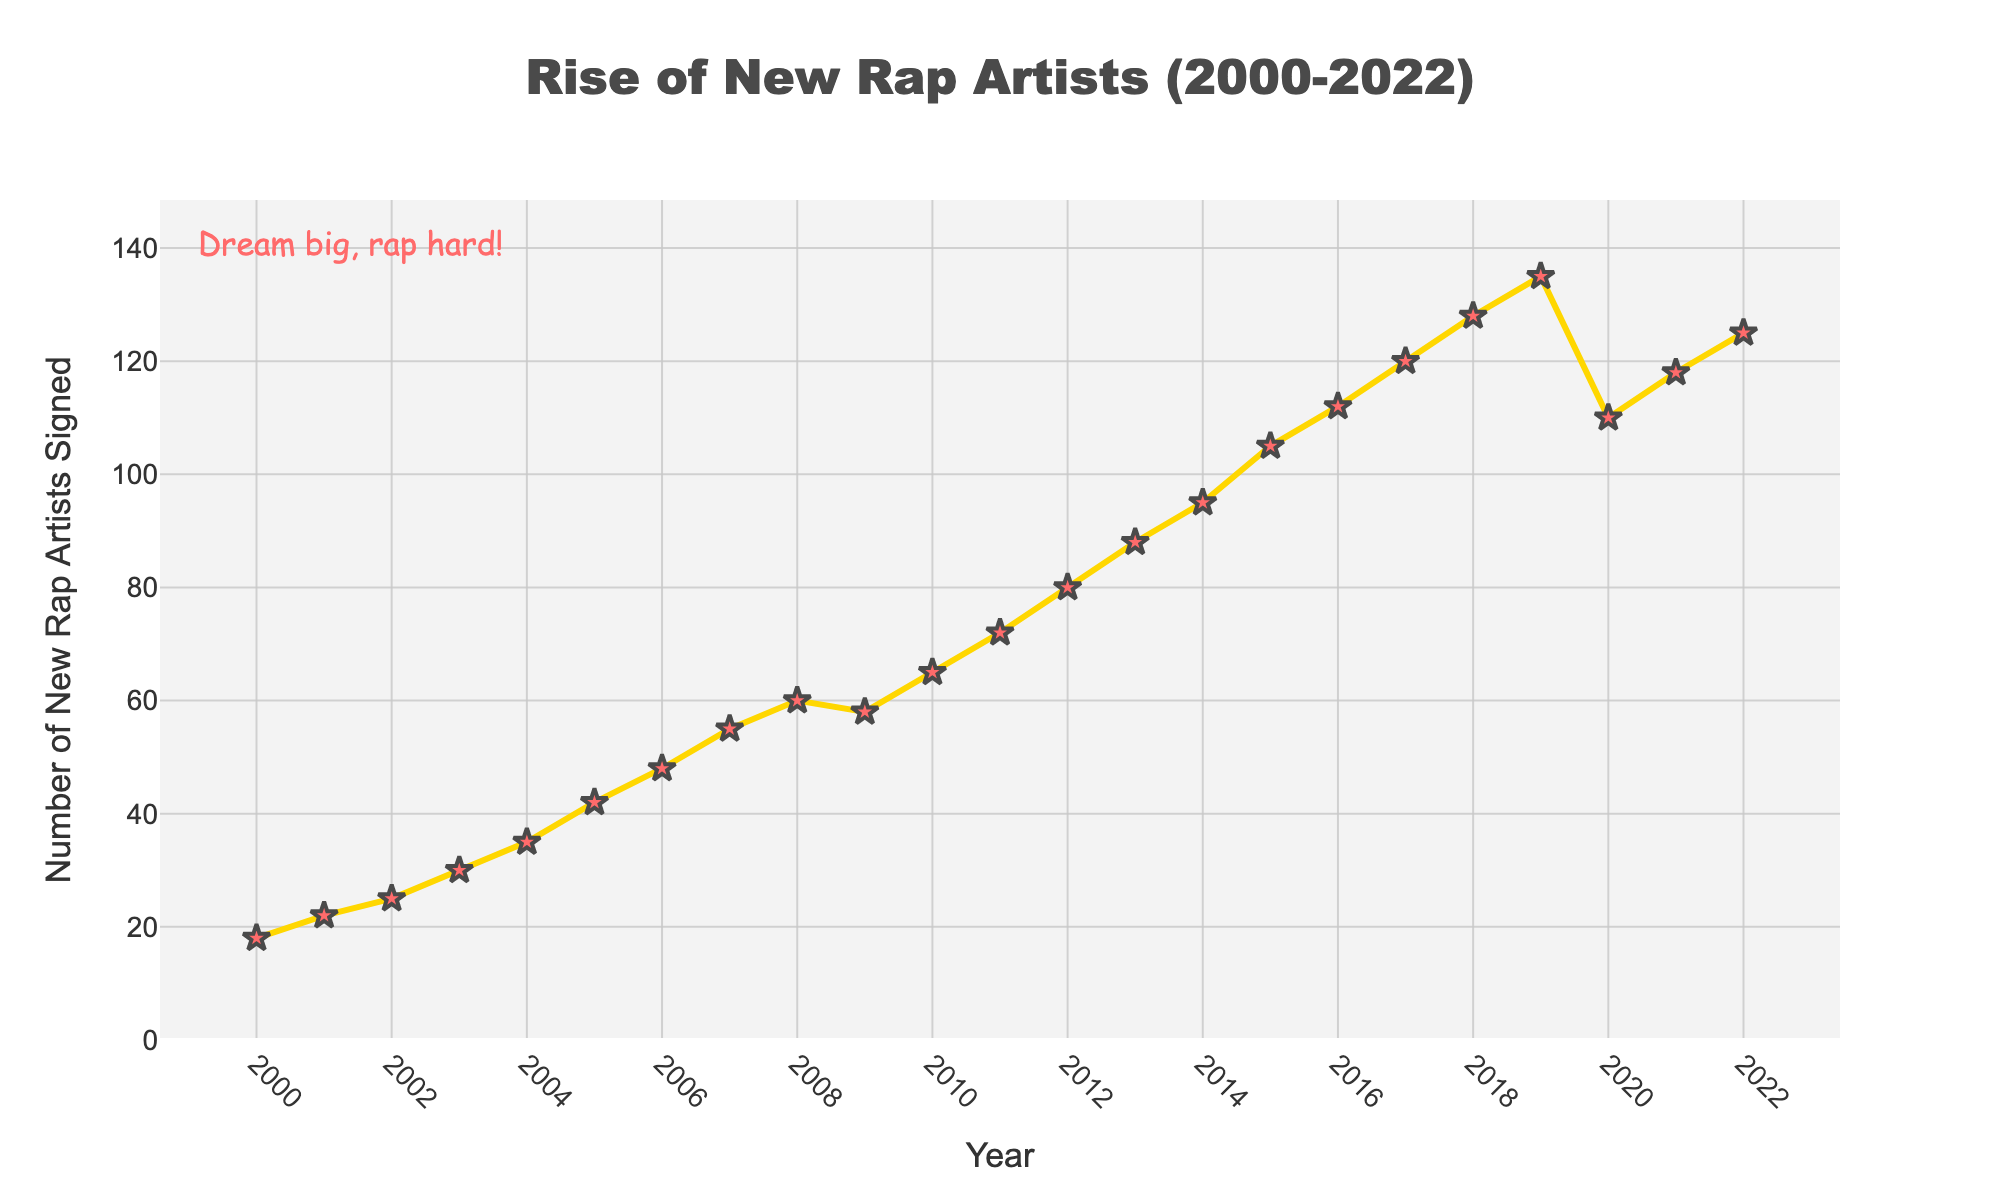what year had the highest number of new rap artists signed? The highest point on the line chart represents the peak number of new rap artists signed. According to the chart, 2019 had the highest number of new rap artists signed, which is 135.
Answer: 2019 By how much did the number of new rap artists signed increase from 2005 to 2010? To find the increase, subtract the number of new rap artists signed in 2005 from the number signed in 2010. 65 (2010) - 42 (2005) = 23.
Answer: 23 Which year showed a slight decrease in the number of new rap artists signed compared to the previous year? The chart shows a decrease in the number of new rap artists signed from 2008 (60) to 2009 (58).
Answer: 2009 What's the average number of new rap artists signed per year from 2015 to 2020? Sum the number of new rap artists signed from 2015 to 2020 and divide by the number of years. (105 + 112 + 120 + 128 + 135 + 110) / 6 = 710 / 6 ≈ 118.33
Answer: 118.33 Compare the number of new rap artists signed in the years 2000 and 2022. According to the chart, 18 new rap artists were signed in 2000, and 125 in 2022. 125 is greater than 18.
Answer: 2022 > 2000 Identify the years where the number of new rap artists signed was lower than in the year 2016. In 2016, 112 new rap artists were signed. Any year with fewer than 112 new artists includes 2000 through 2015.
Answer: 2000-2015 What is the total number of new rap artists signed between 2003 and 2008? Add the number of new rap artists signed from 2003 to 2008. 30 (2003) + 35 (2004) + 42 (2005) + 48 (2006) + 55 (2007) + 60 (2008) = 270.
Answer: 270 What notable trend can be observed in the years between 2019 and 2021? The line chart shows a decline in the number of new rap artists signed from 2019 (135) to 2020 (110), followed by an increase in 2021 (118).
Answer: Decline then increase By how much did the number of new rap artists signed increase from 2002 to 2007? Subtract the number of new rap artists signed in 2007 from 2002: 55 (2007) - 25 (2002) = 30.
Answer: 30 